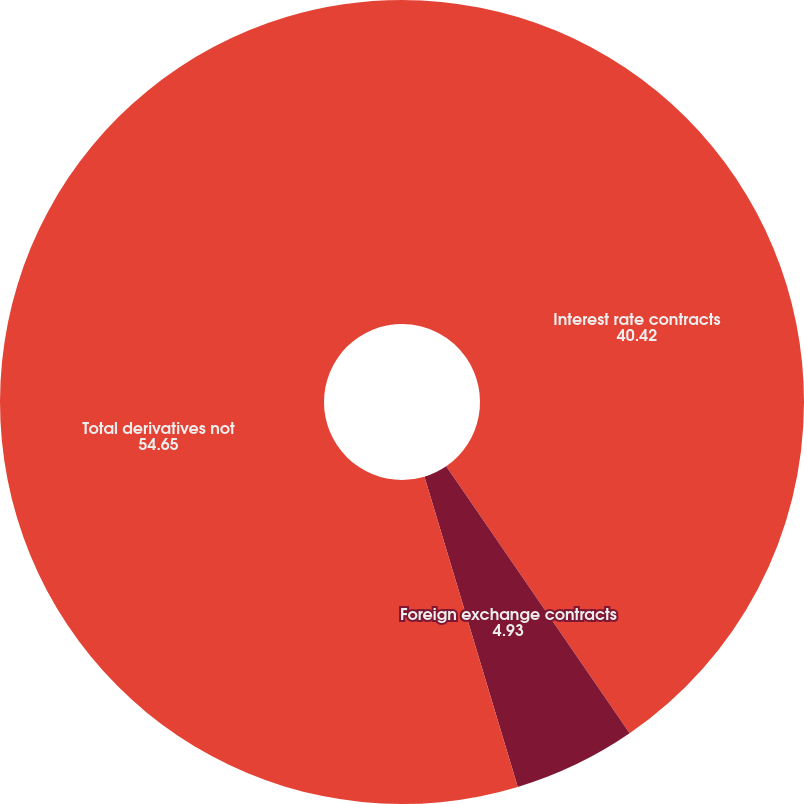Convert chart. <chart><loc_0><loc_0><loc_500><loc_500><pie_chart><fcel>Interest rate contracts<fcel>Foreign exchange contracts<fcel>Total derivatives not<nl><fcel>40.42%<fcel>4.93%<fcel>54.65%<nl></chart> 